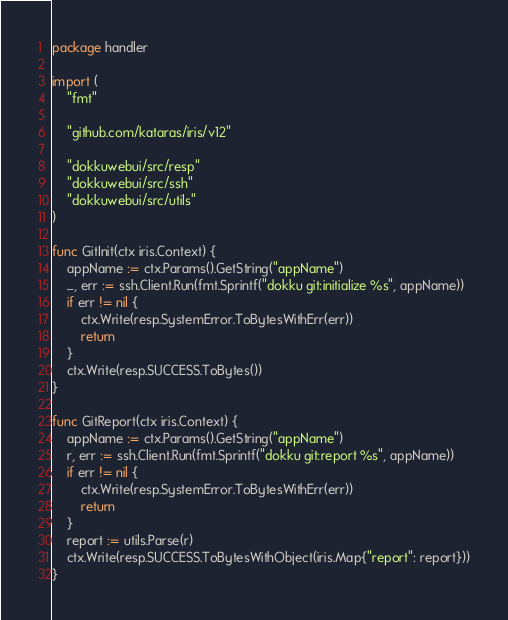Convert code to text. <code><loc_0><loc_0><loc_500><loc_500><_Go_>package handler

import (
	"fmt"

	"github.com/kataras/iris/v12"

	"dokkuwebui/src/resp"
	"dokkuwebui/src/ssh"
	"dokkuwebui/src/utils"
)

func GitInit(ctx iris.Context) {
	appName := ctx.Params().GetString("appName")
	_, err := ssh.Client.Run(fmt.Sprintf("dokku git:initialize %s", appName))
	if err != nil {
		ctx.Write(resp.SystemError.ToBytesWithErr(err))
		return
	}
	ctx.Write(resp.SUCCESS.ToBytes())
}

func GitReport(ctx iris.Context) {
	appName := ctx.Params().GetString("appName")
	r, err := ssh.Client.Run(fmt.Sprintf("dokku git:report %s", appName))
	if err != nil {
		ctx.Write(resp.SystemError.ToBytesWithErr(err))
		return
	}
	report := utils.Parse(r)
	ctx.Write(resp.SUCCESS.ToBytesWithObject(iris.Map{"report": report}))
}
</code> 